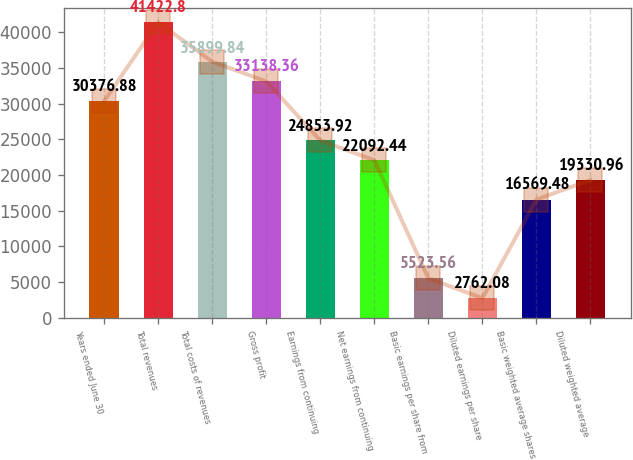Convert chart. <chart><loc_0><loc_0><loc_500><loc_500><bar_chart><fcel>Years ended June 30<fcel>Total revenues<fcel>Total costs of revenues<fcel>Gross profit<fcel>Earnings from continuing<fcel>Net earnings from continuing<fcel>Basic earnings per share from<fcel>Diluted earnings per share<fcel>Basic weighted average shares<fcel>Diluted weighted average<nl><fcel>30376.9<fcel>41422.8<fcel>35899.8<fcel>33138.4<fcel>24853.9<fcel>22092.4<fcel>5523.56<fcel>2762.08<fcel>16569.5<fcel>19331<nl></chart> 